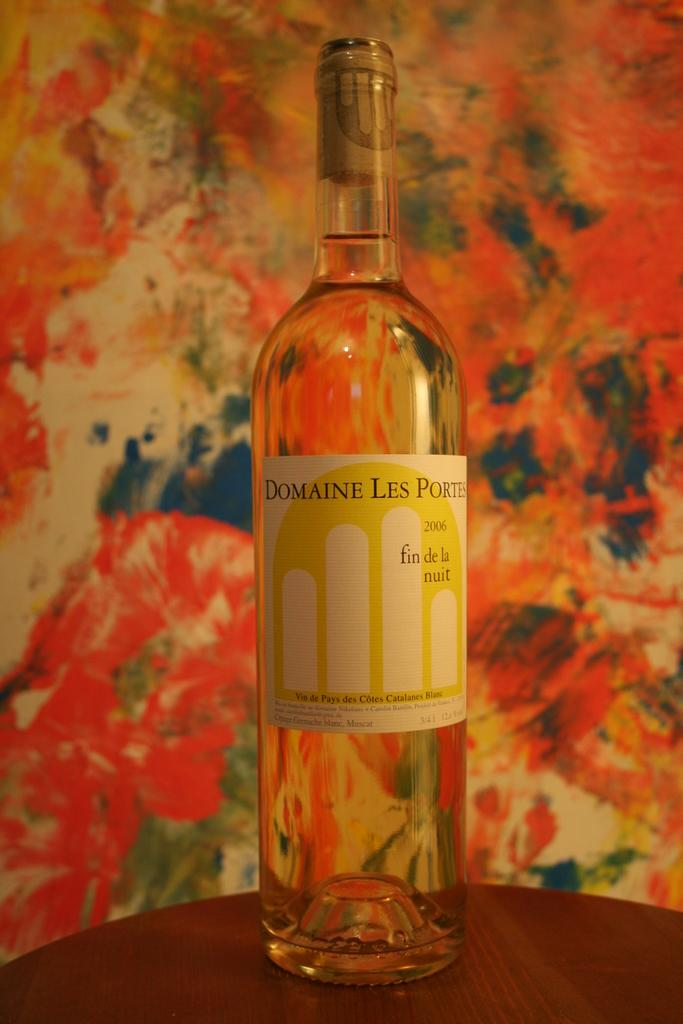<image>
Provide a brief description of the given image. bottle of 2006 domaine les portes on a round table in front of colorful wall 